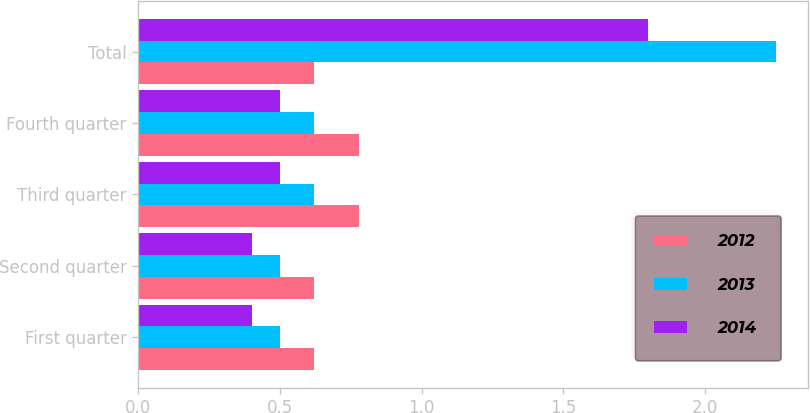<chart> <loc_0><loc_0><loc_500><loc_500><stacked_bar_chart><ecel><fcel>First quarter<fcel>Second quarter<fcel>Third quarter<fcel>Fourth quarter<fcel>Total<nl><fcel>2012<fcel>0.62<fcel>0.62<fcel>0.78<fcel>0.78<fcel>0.62<nl><fcel>2013<fcel>0.5<fcel>0.5<fcel>0.62<fcel>0.62<fcel>2.25<nl><fcel>2014<fcel>0.4<fcel>0.4<fcel>0.5<fcel>0.5<fcel>1.8<nl></chart> 